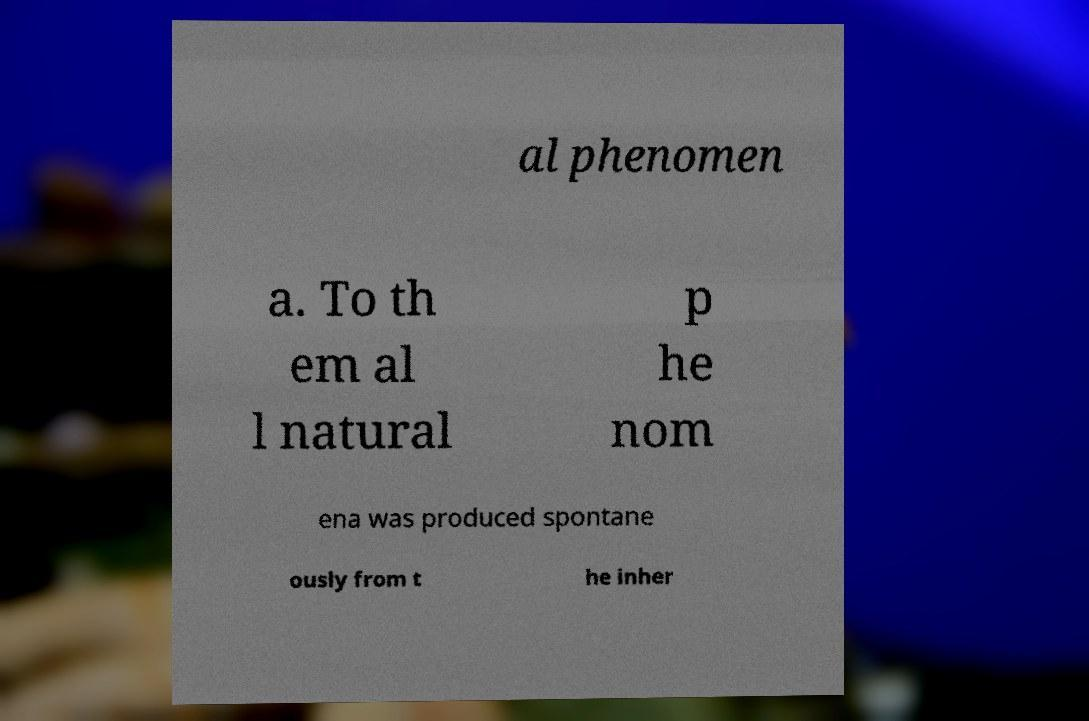Please identify and transcribe the text found in this image. al phenomen a. To th em al l natural p he nom ena was produced spontane ously from t he inher 